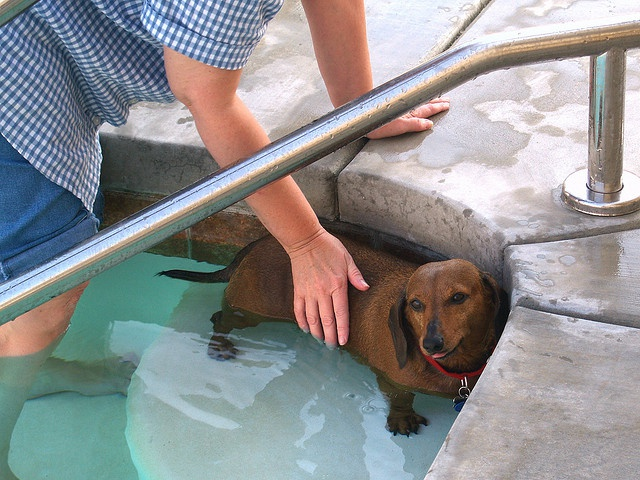Describe the objects in this image and their specific colors. I can see people in lightblue, brown, gray, and blue tones and dog in lightblue, black, maroon, and brown tones in this image. 